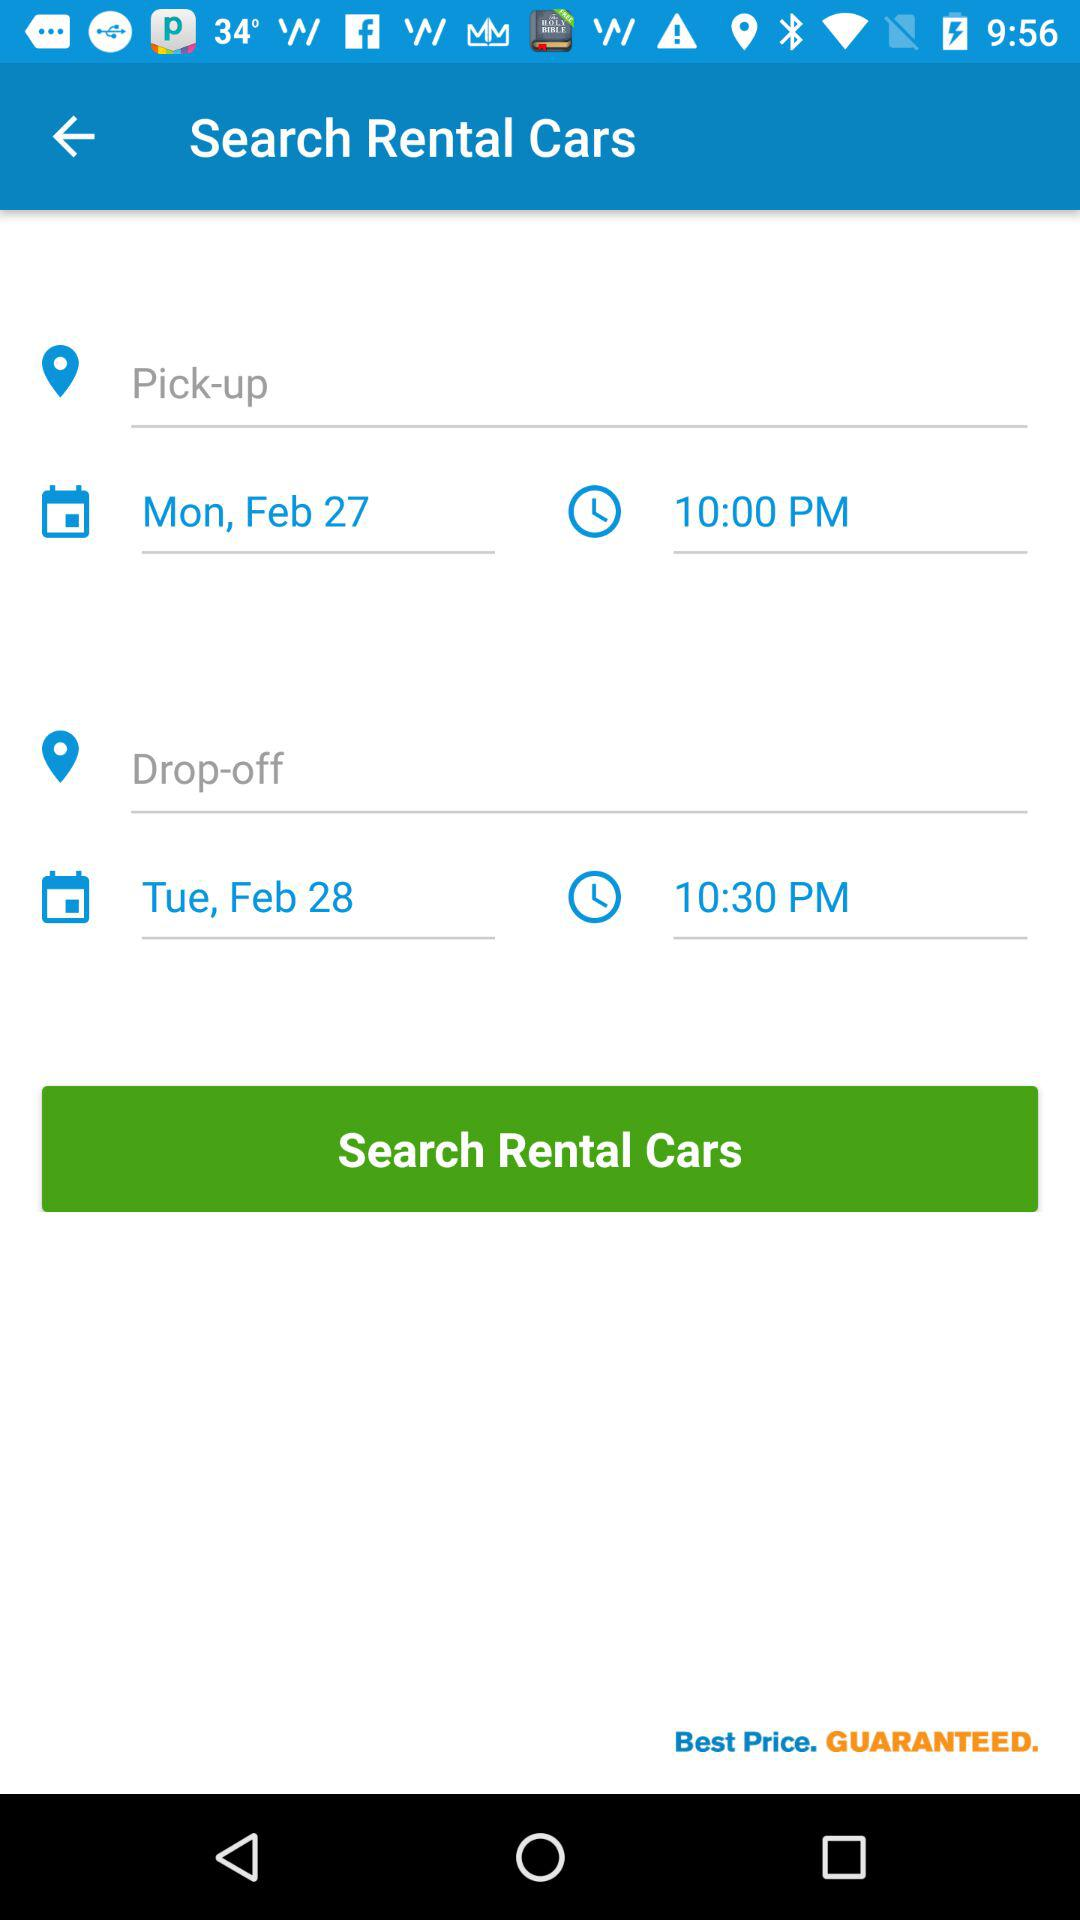What is the time of drop-off? The time of drop-off is 10:30 p.m. 